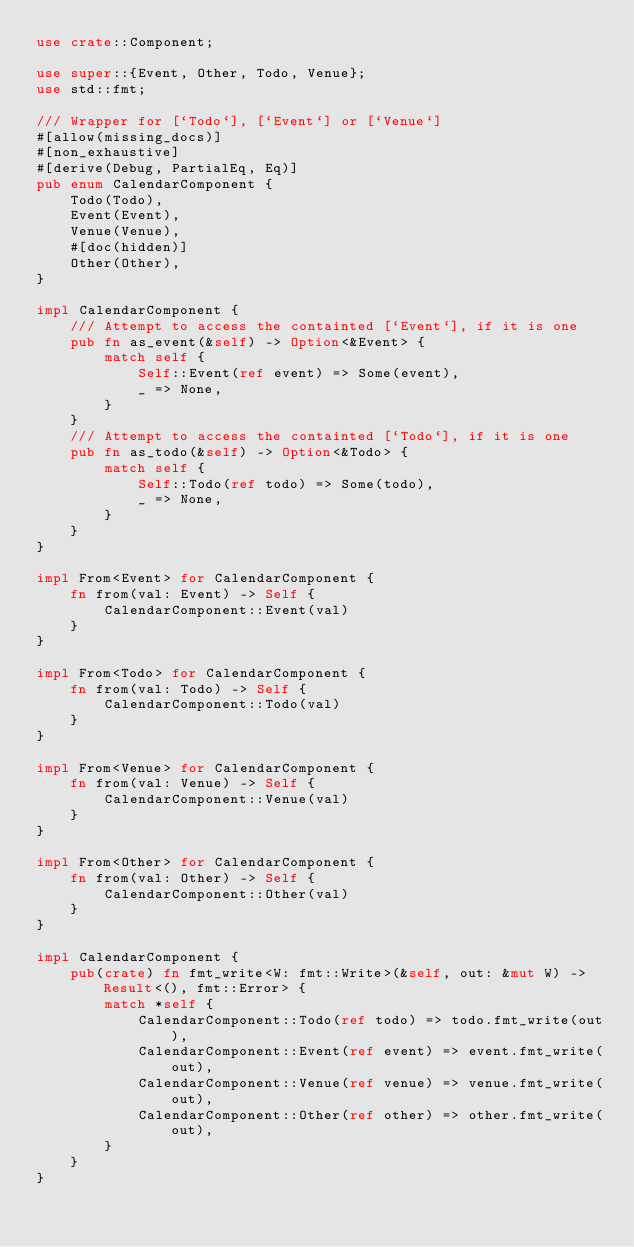Convert code to text. <code><loc_0><loc_0><loc_500><loc_500><_Rust_>use crate::Component;

use super::{Event, Other, Todo, Venue};
use std::fmt;

/// Wrapper for [`Todo`], [`Event`] or [`Venue`]
#[allow(missing_docs)]
#[non_exhaustive]
#[derive(Debug, PartialEq, Eq)]
pub enum CalendarComponent {
    Todo(Todo),
    Event(Event),
    Venue(Venue),
    #[doc(hidden)]
    Other(Other),
}

impl CalendarComponent {
    /// Attempt to access the containted [`Event`], if it is one
    pub fn as_event(&self) -> Option<&Event> {
        match self {
            Self::Event(ref event) => Some(event),
            _ => None,
        }
    }
    /// Attempt to access the containted [`Todo`], if it is one
    pub fn as_todo(&self) -> Option<&Todo> {
        match self {
            Self::Todo(ref todo) => Some(todo),
            _ => None,
        }
    }
}

impl From<Event> for CalendarComponent {
    fn from(val: Event) -> Self {
        CalendarComponent::Event(val)
    }
}

impl From<Todo> for CalendarComponent {
    fn from(val: Todo) -> Self {
        CalendarComponent::Todo(val)
    }
}

impl From<Venue> for CalendarComponent {
    fn from(val: Venue) -> Self {
        CalendarComponent::Venue(val)
    }
}

impl From<Other> for CalendarComponent {
    fn from(val: Other) -> Self {
        CalendarComponent::Other(val)
    }
}

impl CalendarComponent {
    pub(crate) fn fmt_write<W: fmt::Write>(&self, out: &mut W) -> Result<(), fmt::Error> {
        match *self {
            CalendarComponent::Todo(ref todo) => todo.fmt_write(out),
            CalendarComponent::Event(ref event) => event.fmt_write(out),
            CalendarComponent::Venue(ref venue) => venue.fmt_write(out),
            CalendarComponent::Other(ref other) => other.fmt_write(out),
        }
    }
}
</code> 